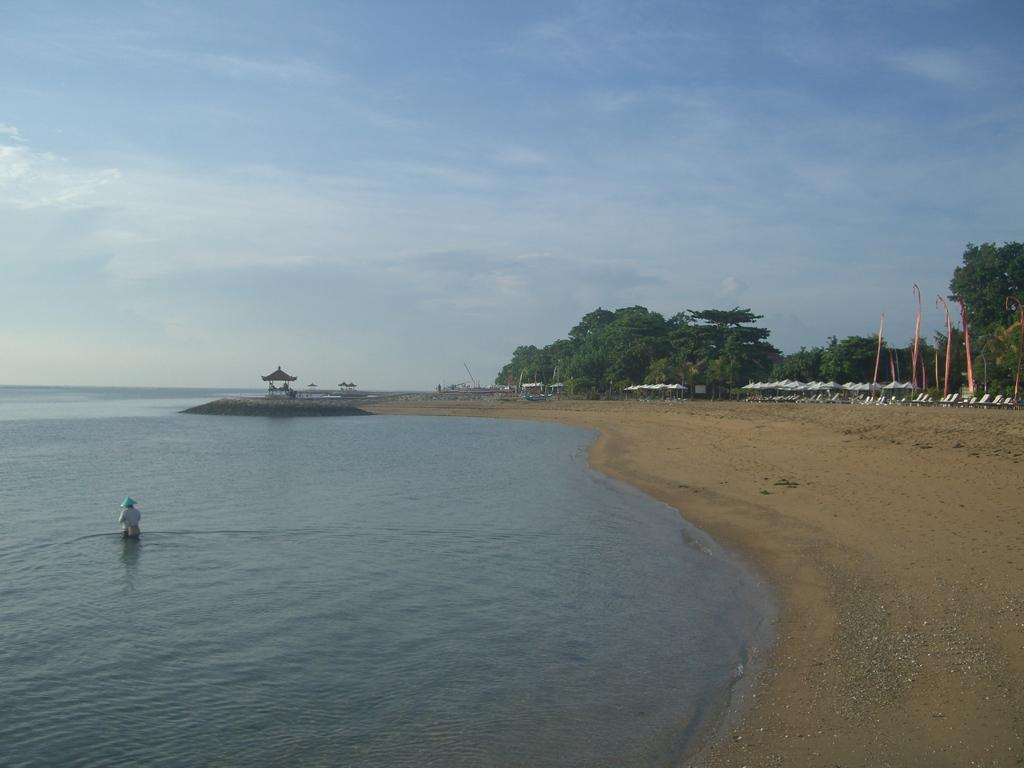What is the main element present in the image? There is water in the image. Can you describe the person in the image? There is a person standing in the image. What type of vegetation is visible in the image? There are trees in the image. What objects are being used for protection from the elements? There are umbrellas in the image. What part of the natural environment is visible in the image? The sky is visible in the image. What can be observed in the sky? Clouds are present in the sky. What type of drug is being sold by the person in the image? There is no indication in the image that the person is selling any drugs, and drugs are not present in the image. What type of soda is being consumed by the person in the image? There is no soda present in the image, and the person's actions are not described in enough detail to determine if they are consuming any beverage. 